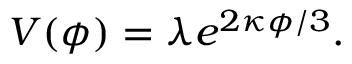Convert formula to latex. <formula><loc_0><loc_0><loc_500><loc_500>V ( \phi ) = \lambda e ^ { 2 \kappa \phi / 3 } .</formula> 